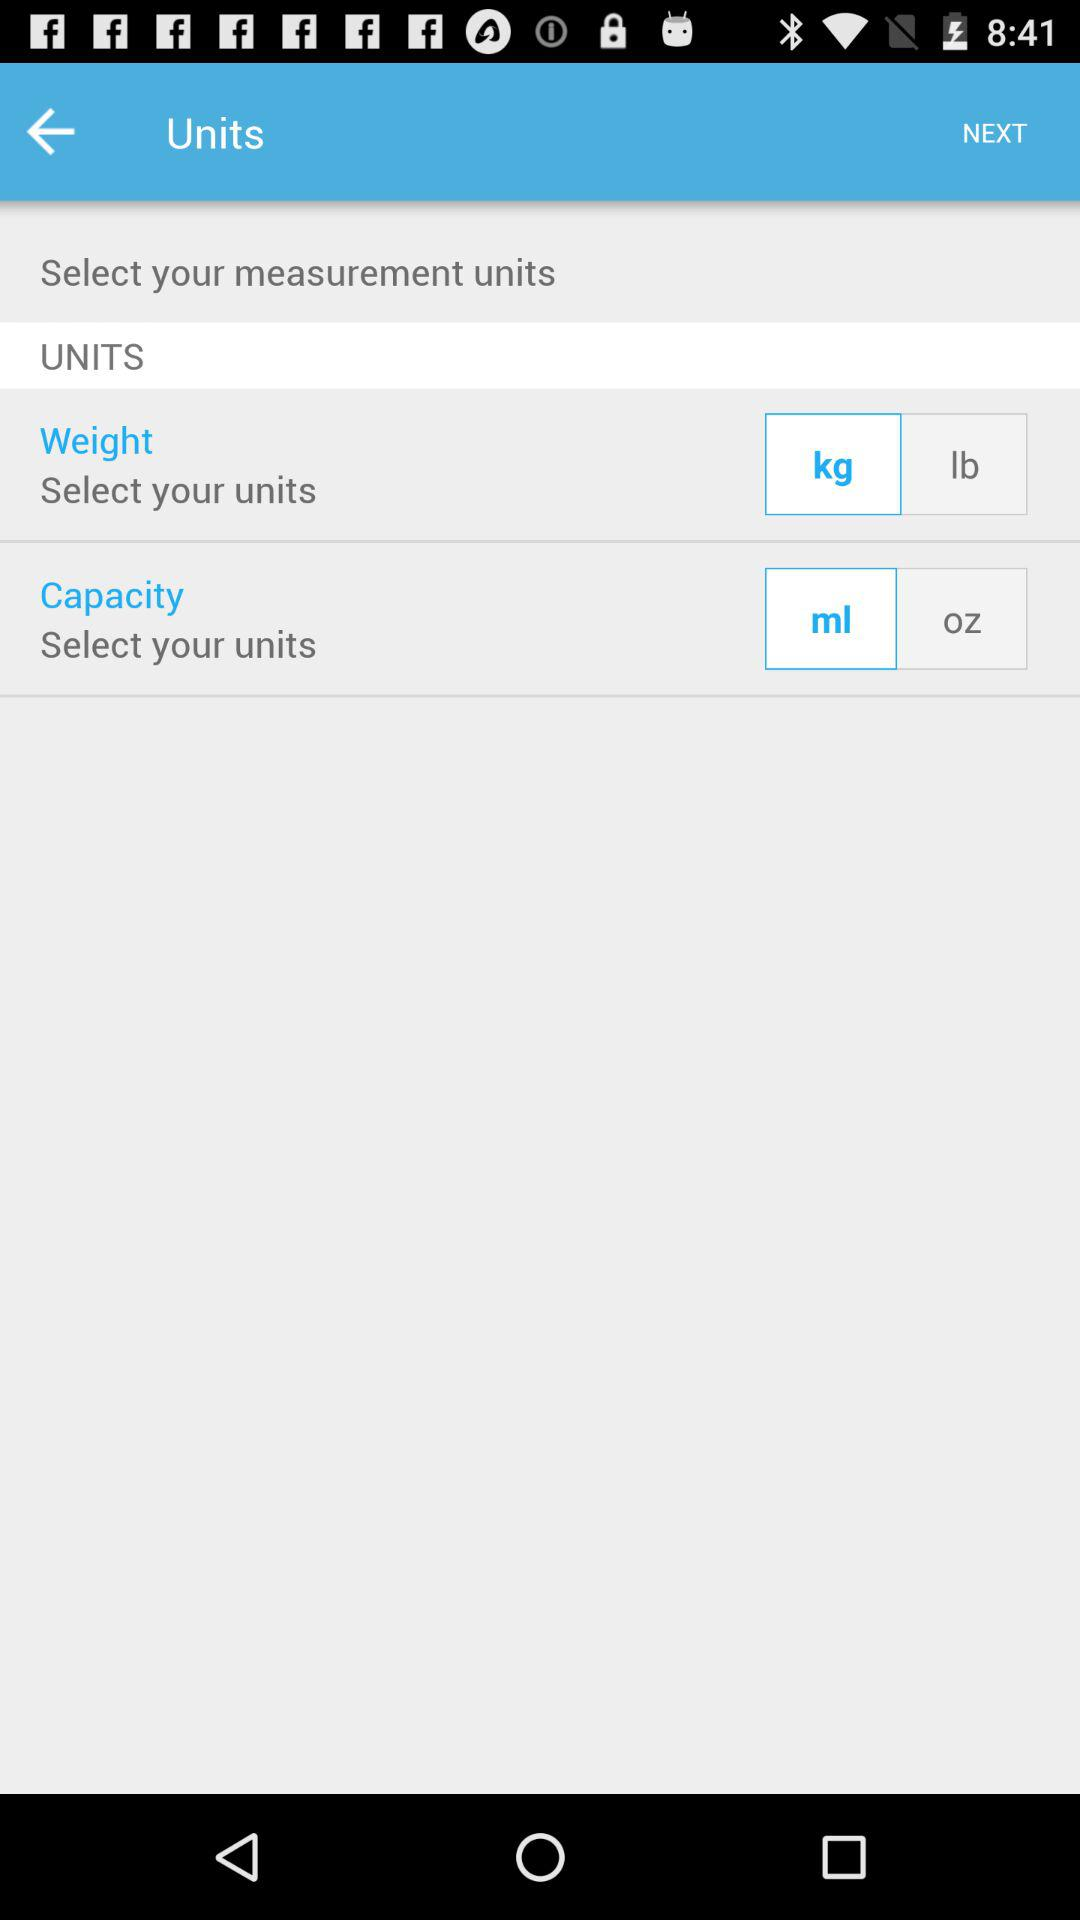How many units are there for weight?
Answer the question using a single word or phrase. 2 